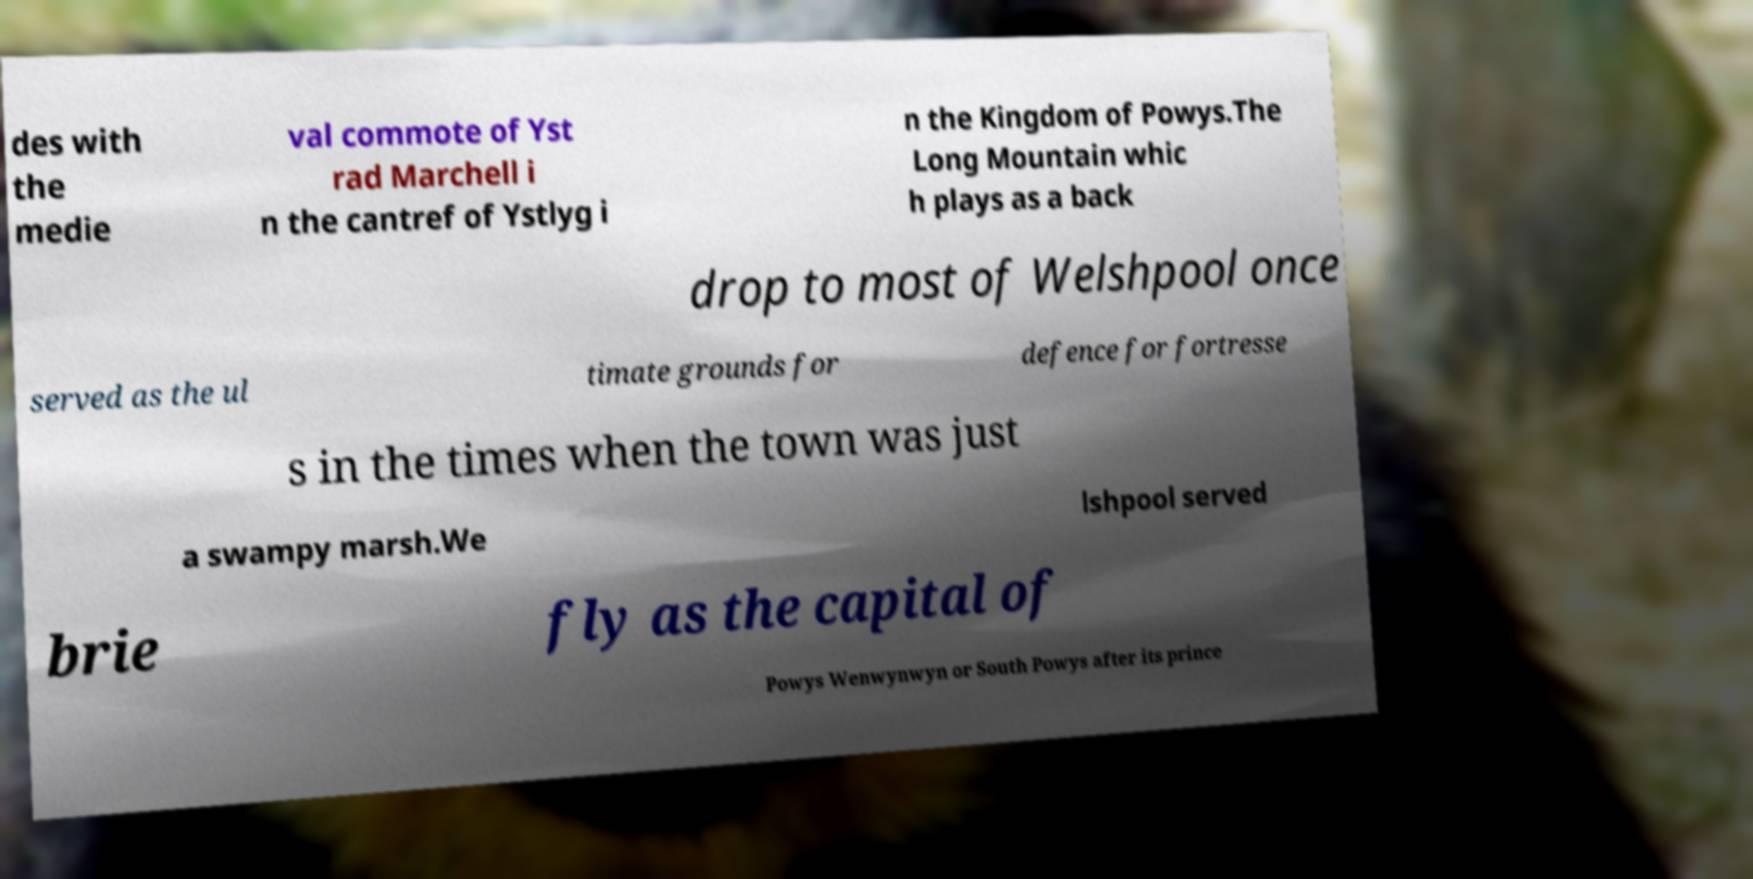Please identify and transcribe the text found in this image. des with the medie val commote of Yst rad Marchell i n the cantref of Ystlyg i n the Kingdom of Powys.The Long Mountain whic h plays as a back drop to most of Welshpool once served as the ul timate grounds for defence for fortresse s in the times when the town was just a swampy marsh.We lshpool served brie fly as the capital of Powys Wenwynwyn or South Powys after its prince 